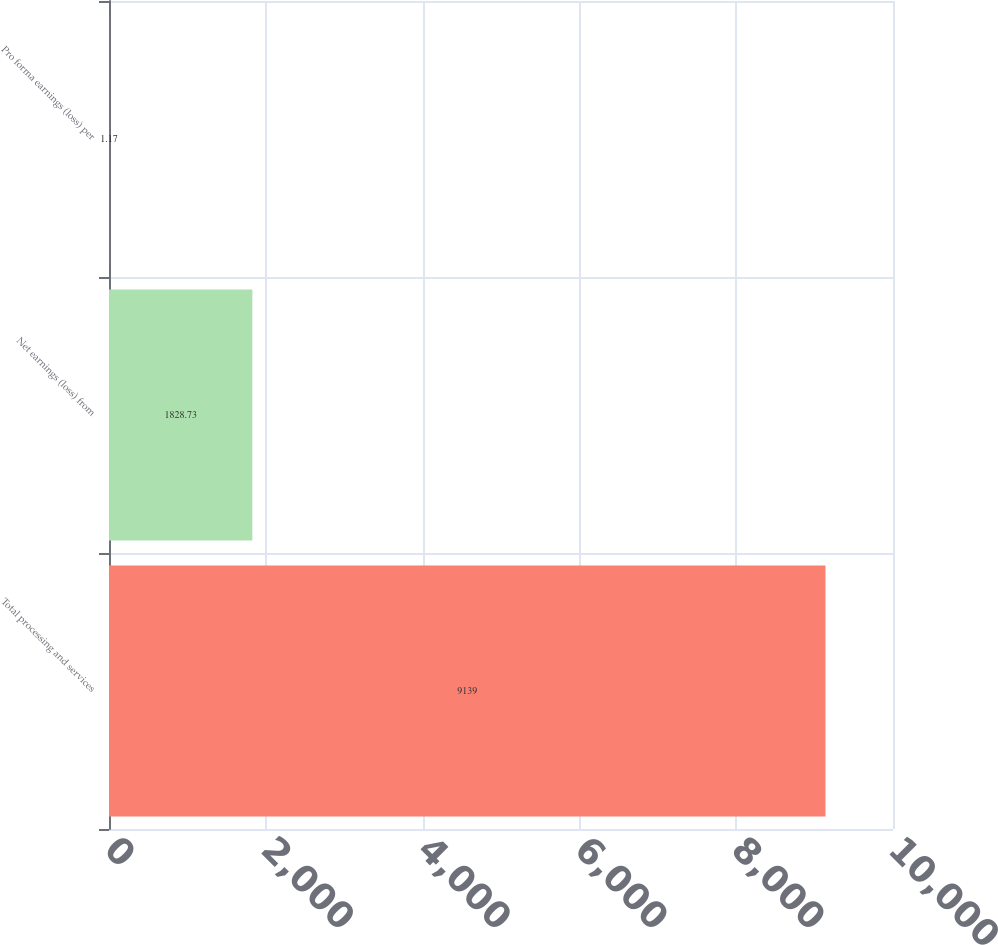<chart> <loc_0><loc_0><loc_500><loc_500><bar_chart><fcel>Total processing and services<fcel>Net earnings (loss) from<fcel>Pro forma earnings (loss) per<nl><fcel>9139<fcel>1828.73<fcel>1.17<nl></chart> 